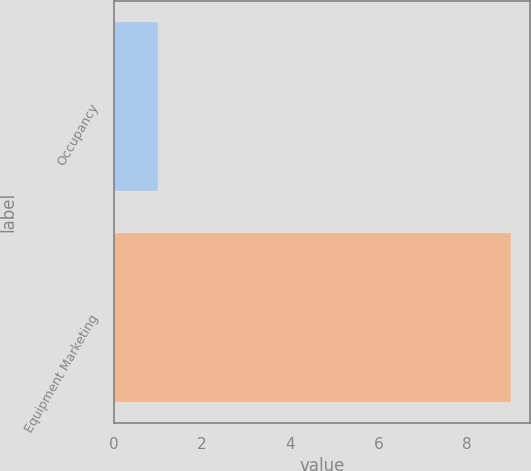Convert chart. <chart><loc_0><loc_0><loc_500><loc_500><bar_chart><fcel>Occupancy<fcel>Equipment Marketing<nl><fcel>1<fcel>9<nl></chart> 